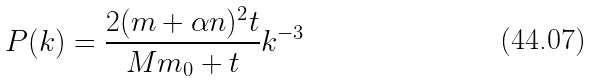<formula> <loc_0><loc_0><loc_500><loc_500>P ( k ) = \frac { 2 ( m + \alpha n ) ^ { 2 } t } { M m _ { 0 } + t } k ^ { - 3 }</formula> 